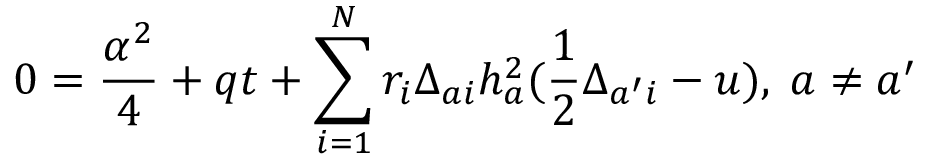Convert formula to latex. <formula><loc_0><loc_0><loc_500><loc_500>0 = { \frac { \alpha ^ { 2 } } { 4 } } + q t + \sum _ { i = 1 } ^ { N } r _ { i } \Delta _ { a i } h _ { a } ^ { 2 } ( { \frac { 1 } { 2 } } \Delta _ { a ^ { \prime } i } - u ) , \, a \not = a ^ { \prime }</formula> 